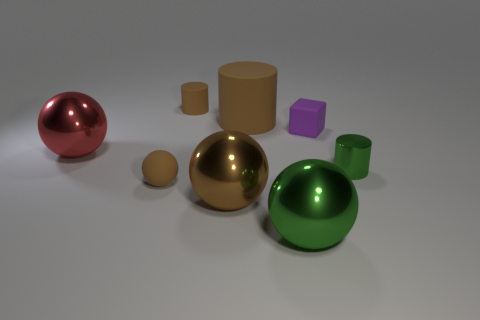Subtract all tiny brown spheres. How many spheres are left? 3 Subtract all green spheres. How many spheres are left? 3 Subtract 0 cyan blocks. How many objects are left? 8 Subtract all cylinders. How many objects are left? 5 Subtract 2 spheres. How many spheres are left? 2 Subtract all yellow balls. Subtract all brown cylinders. How many balls are left? 4 Subtract all green cylinders. How many yellow blocks are left? 0 Subtract all small brown cylinders. Subtract all metal objects. How many objects are left? 3 Add 5 large brown metallic spheres. How many large brown metallic spheres are left? 6 Add 8 green cylinders. How many green cylinders exist? 9 